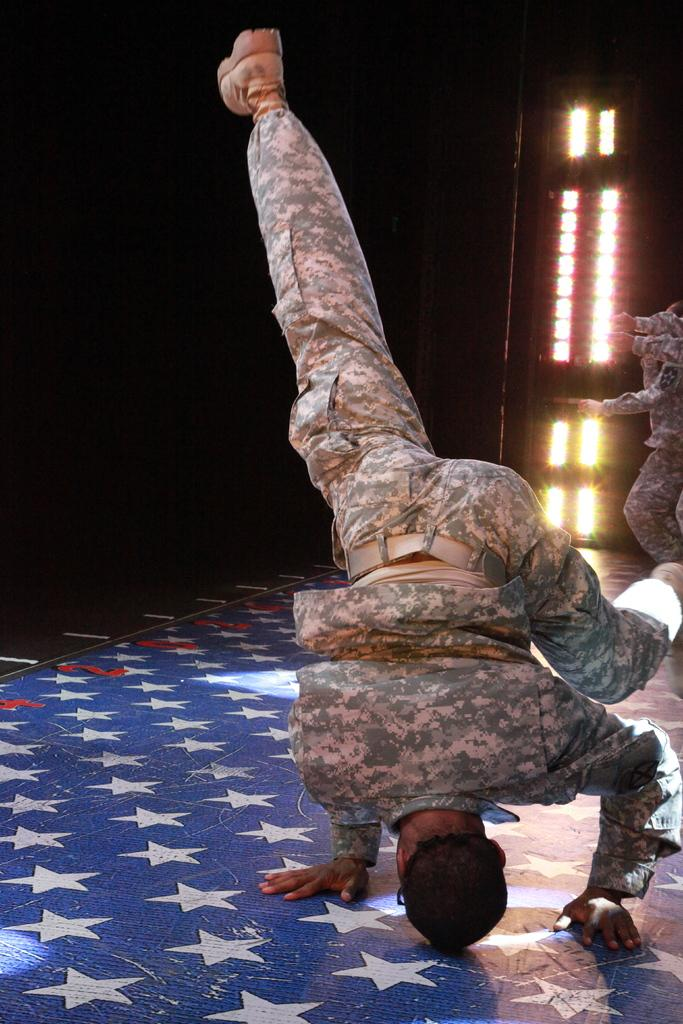How many people are on the stage in the image? There are two people on the stage in the image. What can be seen on the backside of the stage? There are lights visible on the backside of the stage. What type of airport is visible in the image? There is no airport visible in the image; it features a stage with two people and lights on the backside. 